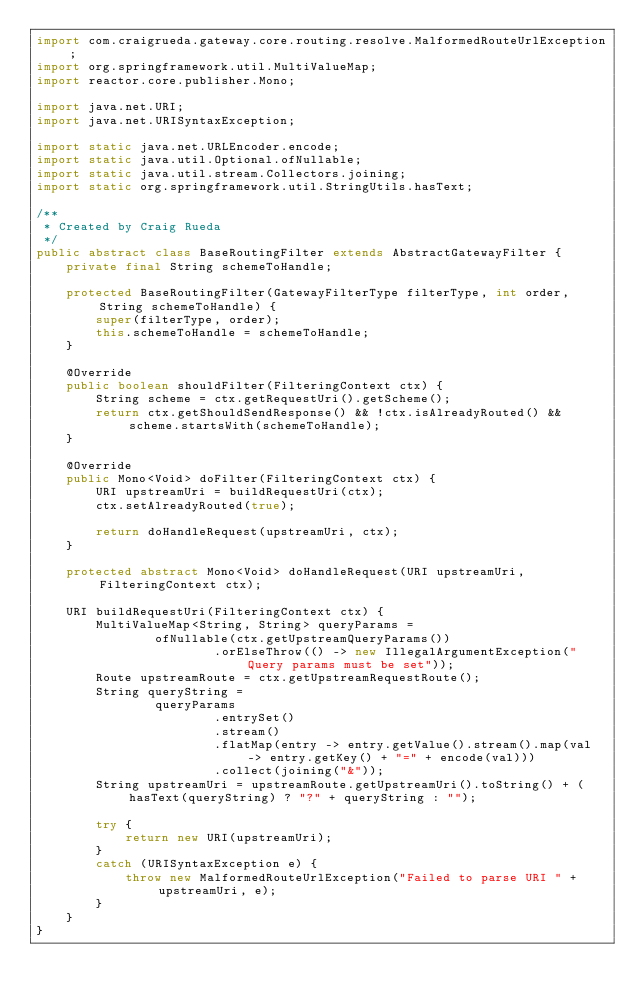<code> <loc_0><loc_0><loc_500><loc_500><_Java_>import com.craigrueda.gateway.core.routing.resolve.MalformedRouteUrlException;
import org.springframework.util.MultiValueMap;
import reactor.core.publisher.Mono;

import java.net.URI;
import java.net.URISyntaxException;

import static java.net.URLEncoder.encode;
import static java.util.Optional.ofNullable;
import static java.util.stream.Collectors.joining;
import static org.springframework.util.StringUtils.hasText;

/**
 * Created by Craig Rueda
 */
public abstract class BaseRoutingFilter extends AbstractGatewayFilter {
    private final String schemeToHandle;

    protected BaseRoutingFilter(GatewayFilterType filterType, int order, String schemeToHandle) {
        super(filterType, order);
        this.schemeToHandle = schemeToHandle;
    }

    @Override
    public boolean shouldFilter(FilteringContext ctx) {
        String scheme = ctx.getRequestUri().getScheme();
        return ctx.getShouldSendResponse() && !ctx.isAlreadyRouted() && scheme.startsWith(schemeToHandle);
    }

    @Override
    public Mono<Void> doFilter(FilteringContext ctx) {
        URI upstreamUri = buildRequestUri(ctx);
        ctx.setAlreadyRouted(true);

        return doHandleRequest(upstreamUri, ctx);
    }

    protected abstract Mono<Void> doHandleRequest(URI upstreamUri, FilteringContext ctx);

    URI buildRequestUri(FilteringContext ctx) {
        MultiValueMap<String, String> queryParams =
                ofNullable(ctx.getUpstreamQueryParams())
                        .orElseThrow(() -> new IllegalArgumentException("Query params must be set"));
        Route upstreamRoute = ctx.getUpstreamRequestRoute();
        String queryString =
                queryParams
                        .entrySet()
                        .stream()
                        .flatMap(entry -> entry.getValue().stream().map(val -> entry.getKey() + "=" + encode(val)))
                        .collect(joining("&"));
        String upstreamUri = upstreamRoute.getUpstreamUri().toString() + (hasText(queryString) ? "?" + queryString : "");

        try {
            return new URI(upstreamUri);
        }
        catch (URISyntaxException e) {
            throw new MalformedRouteUrlException("Failed to parse URI " + upstreamUri, e);
        }
    }
}
</code> 